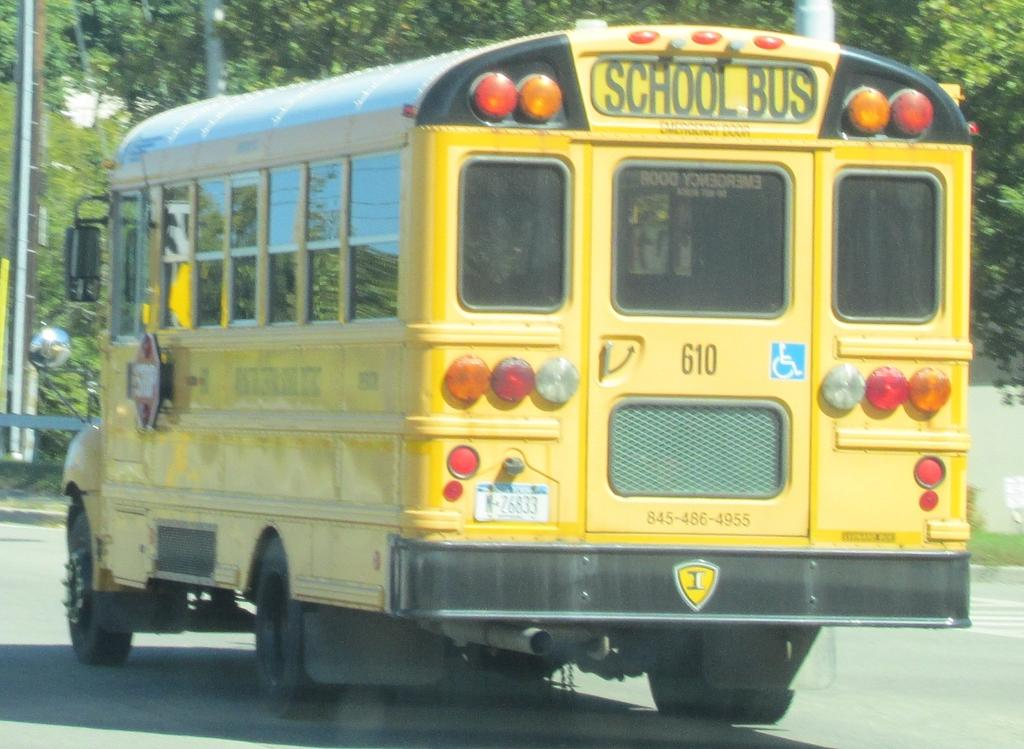What is the main subject of the image? The main subject of the image is a school bus. What can be seen in the background of the image? There are electric poles and trees in the background of the image. What type of news can be seen being delivered by the train in the image? There is no train present in the image, so it is not possible to determine what type of news might be delivered. 